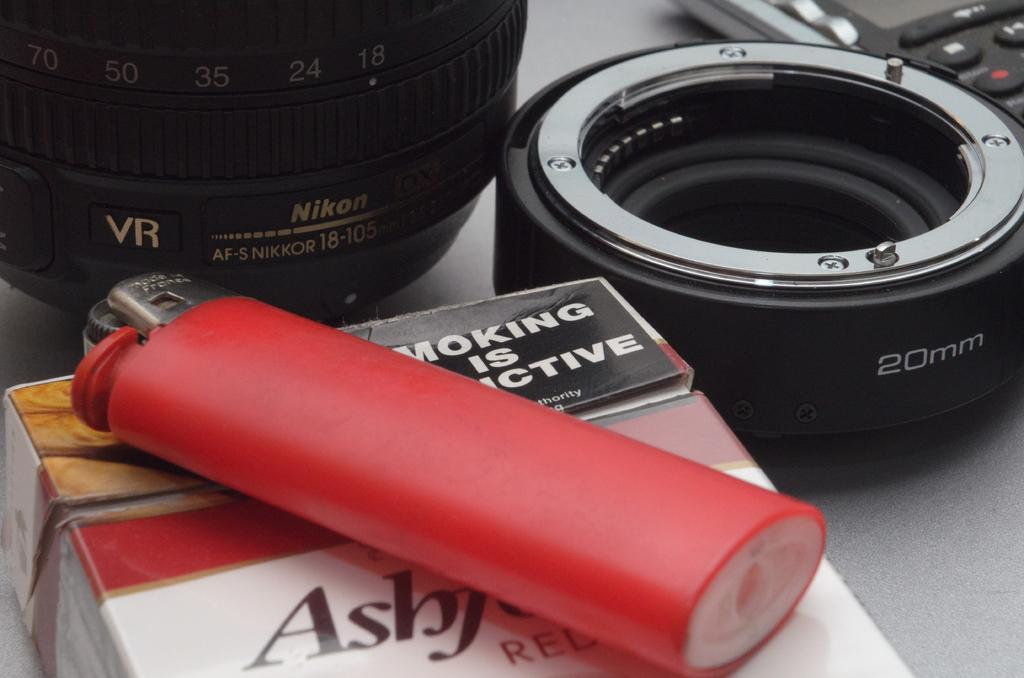What object related to smoking can be seen in the image? There is a cigarette box in the image. What item is used for igniting the cigarette? There is a lighter in the image. What type of equipment is present for photography purposes? There are camera lenses in the image. How many crackers are included in the camera lenses in the image? There are no crackers present in the image, as it features a cigarette box, a lighter, and camera lenses. What type of cast is visible on the cigarette box in the image? There is no cast visible on the cigarette box in the image, as it is a simple box for storing cigarettes. 